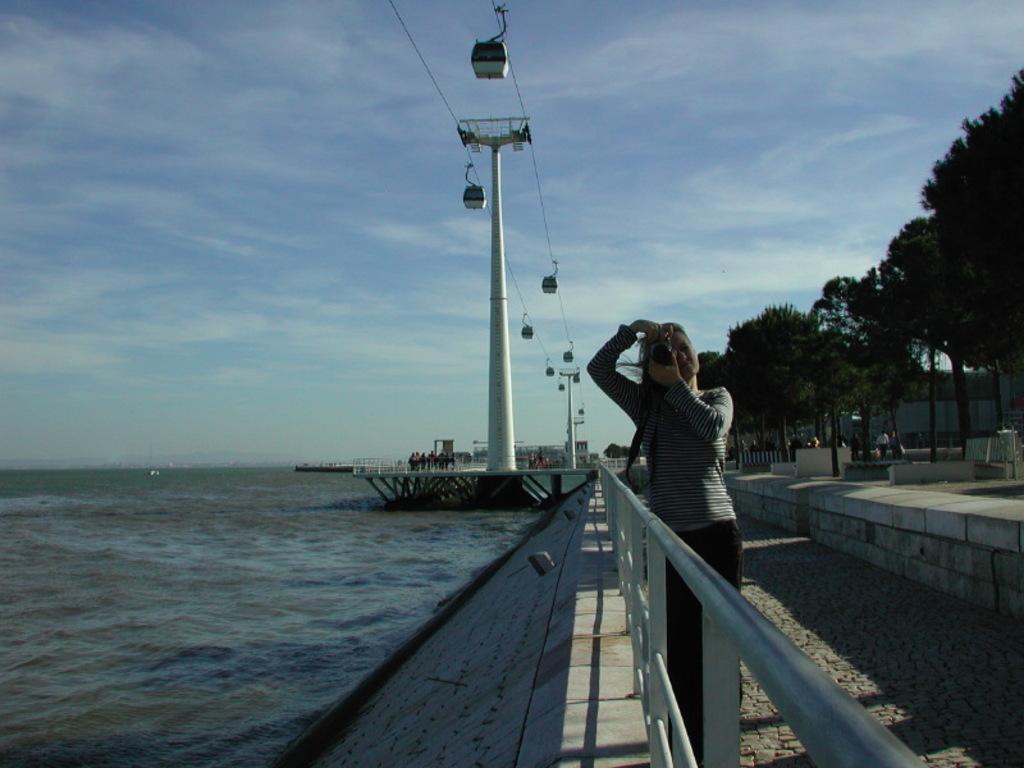Could you give a brief overview of what you see in this image? In this picture we can see a woman on the ground, at the back of her we can see few people, trees, poles, chair lifts and some objects and in the background we can see water and the sky. 